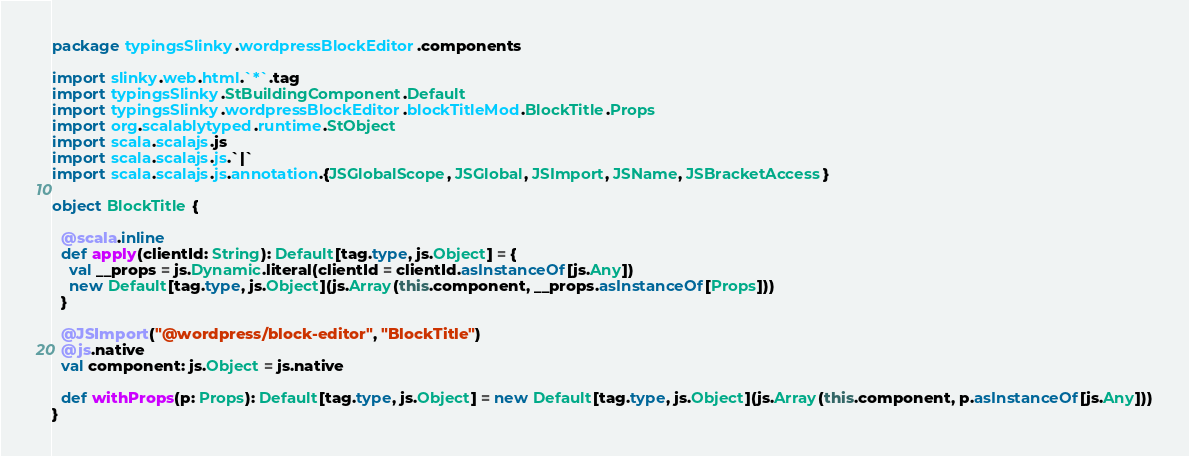<code> <loc_0><loc_0><loc_500><loc_500><_Scala_>package typingsSlinky.wordpressBlockEditor.components

import slinky.web.html.`*`.tag
import typingsSlinky.StBuildingComponent.Default
import typingsSlinky.wordpressBlockEditor.blockTitleMod.BlockTitle.Props
import org.scalablytyped.runtime.StObject
import scala.scalajs.js
import scala.scalajs.js.`|`
import scala.scalajs.js.annotation.{JSGlobalScope, JSGlobal, JSImport, JSName, JSBracketAccess}

object BlockTitle {
  
  @scala.inline
  def apply(clientId: String): Default[tag.type, js.Object] = {
    val __props = js.Dynamic.literal(clientId = clientId.asInstanceOf[js.Any])
    new Default[tag.type, js.Object](js.Array(this.component, __props.asInstanceOf[Props]))
  }
  
  @JSImport("@wordpress/block-editor", "BlockTitle")
  @js.native
  val component: js.Object = js.native
  
  def withProps(p: Props): Default[tag.type, js.Object] = new Default[tag.type, js.Object](js.Array(this.component, p.asInstanceOf[js.Any]))
}
</code> 